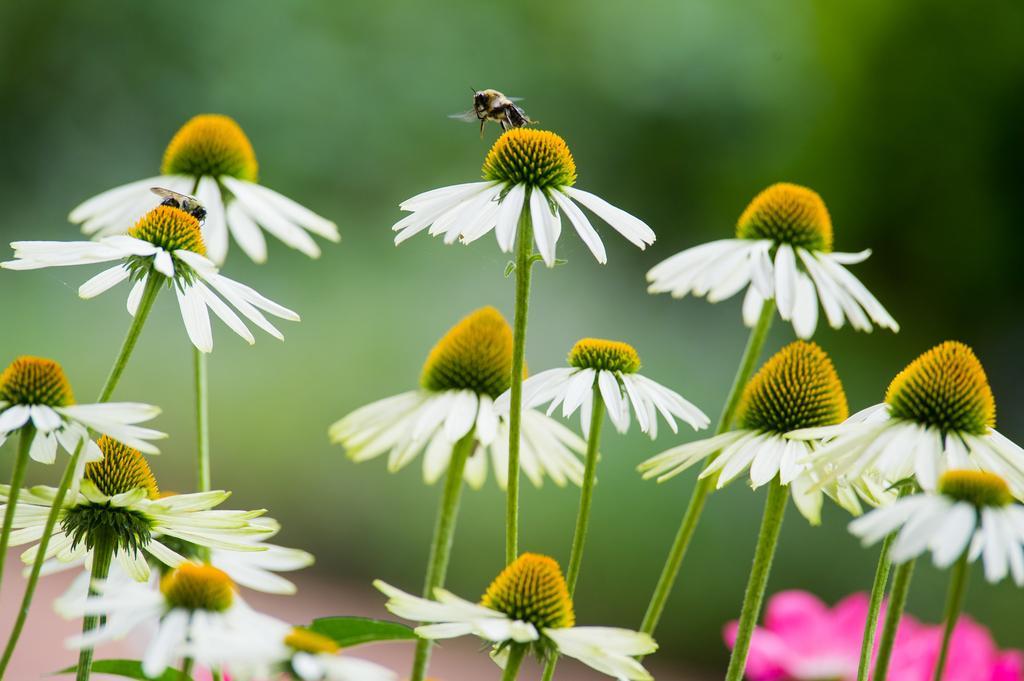How would you summarize this image in a sentence or two? At the top of this image, there is an insect on a white color flower. On the left side, there is an insect on a white color flower and there are flowers. On the right side, there are flowers. And the background is blurred. 